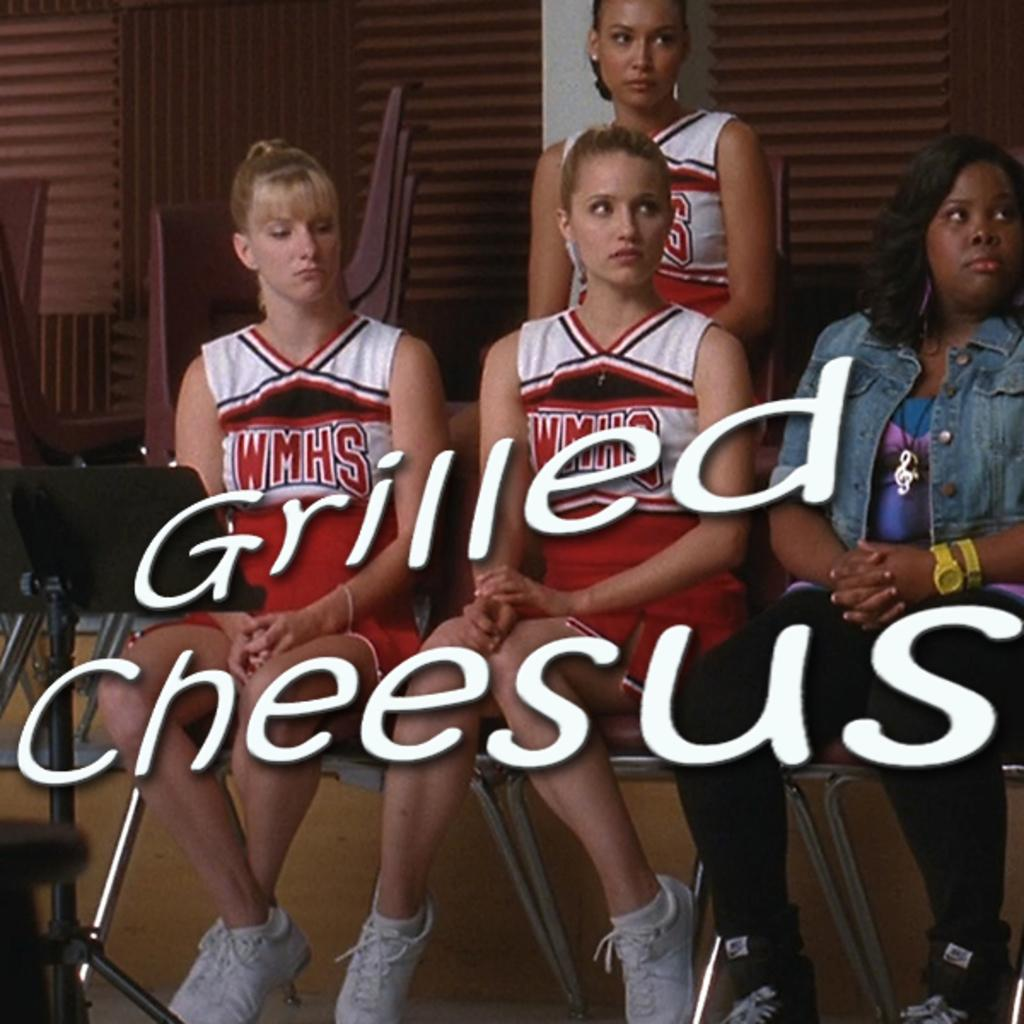How many girls are present in the image? There are 4 girls in the image. What are the girls doing in the image? The girls are sitting on chairs. What is similar about the clothing of three of the girls? Three of the girls are wearing the same dress. What color is the thing mentioned in the image? There is a black color thing in the image. What type of desk can be seen in the image? There is no desk present in the image. 